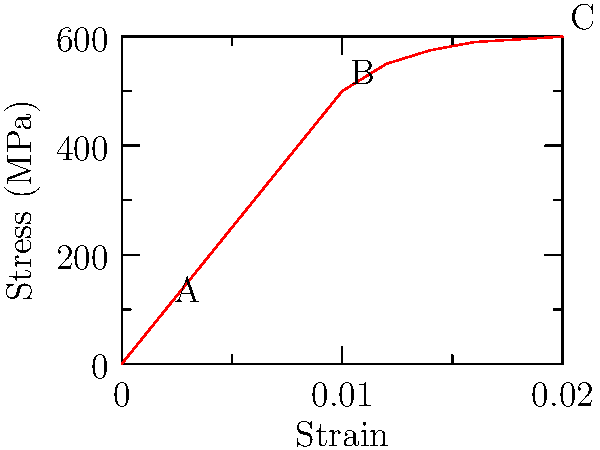In the context of helping trauma victims understand their resilience, consider the stress-strain curve shown above. Which point on the curve represents the yield strength of the material, and how might this relate to a person's ability to cope with stress? To answer this question, let's break down the stress-strain curve and its relation to human resilience:

1. The stress-strain curve represents a material's response to applied force:
   - The x-axis shows strain (deformation)
   - The y-axis shows stress (applied force per unit area)

2. Key points on the curve:
   - Point A: End of the linear elastic region
   - Point B: Yield point
   - Point C: Ultimate strength

3. The yield strength is represented by point B because:
   - It marks the transition from elastic to plastic deformation
   - Beyond this point, the material won't return to its original shape when stress is removed

4. Relating to human resilience:
   - The linear region (up to point A) represents a person's ability to handle stress and bounce back
   - The yield point (B) is like a person's emotional or psychological threshold
   - Beyond point B, a person may experience lasting changes due to trauma

5. In counseling trauma victims:
   - We can use this analogy to explain that everyone has a limit (yield point)
   - Experiencing trauma beyond this point doesn't mean they're broken, but may need support to adapt
   - The curve continues after the yield point, showing that growth and strength are still possible after difficult experiences

The yield strength, represented by point B, is crucial in understanding both material behavior and human resilience in the face of traumatic stress.
Answer: Point B (yield point) 